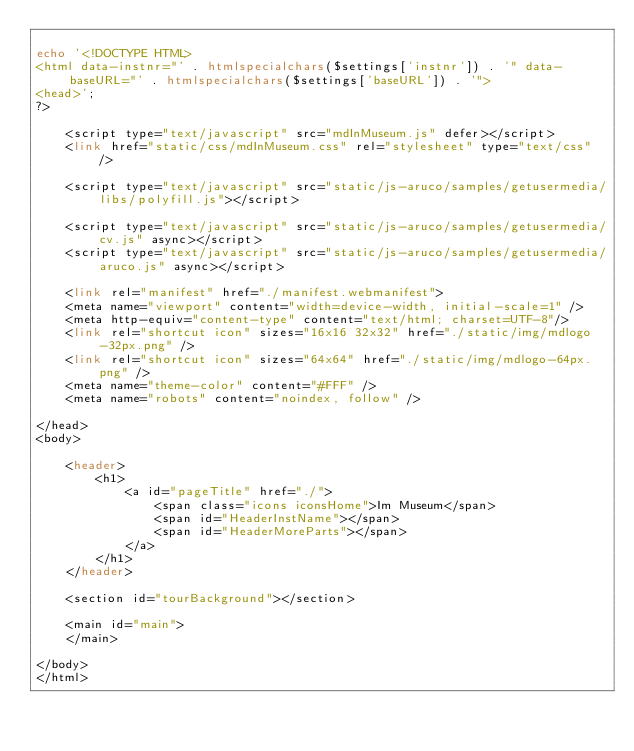<code> <loc_0><loc_0><loc_500><loc_500><_PHP_>
echo '<!DOCTYPE HTML>
<html data-instnr="' . htmlspecialchars($settings['instnr']) . '" data-baseURL="' . htmlspecialchars($settings['baseURL']) . '">
<head>';
?>

    <script type="text/javascript" src="mdInMuseum.js" defer></script>
    <link href="static/css/mdInMuseum.css" rel="stylesheet" type="text/css" />

    <script type="text/javascript" src="static/js-aruco/samples/getusermedia/libs/polyfill.js"></script>

    <script type="text/javascript" src="static/js-aruco/samples/getusermedia/cv.js" async></script>
    <script type="text/javascript" src="static/js-aruco/samples/getusermedia/aruco.js" async></script>

    <link rel="manifest" href="./manifest.webmanifest">
    <meta name="viewport" content="width=device-width, initial-scale=1" />
    <meta http-equiv="content-type" content="text/html; charset=UTF-8"/>
    <link rel="shortcut icon" sizes="16x16 32x32" href="./static/img/mdlogo-32px.png" />
    <link rel="shortcut icon" sizes="64x64" href="./static/img/mdlogo-64px.png" />
    <meta name="theme-color" content="#FFF" />
    <meta name="robots" content="noindex, follow" />

</head>
<body>

    <header>
        <h1>
            <a id="pageTitle" href="./">
                <span class="icons iconsHome">Im Museum</span>
                <span id="HeaderInstName"></span>
                <span id="HeaderMoreParts"></span>
            </a>
        </h1>
    </header>

    <section id="tourBackground"></section>

    <main id="main">
    </main>

</body>
</html>
</code> 